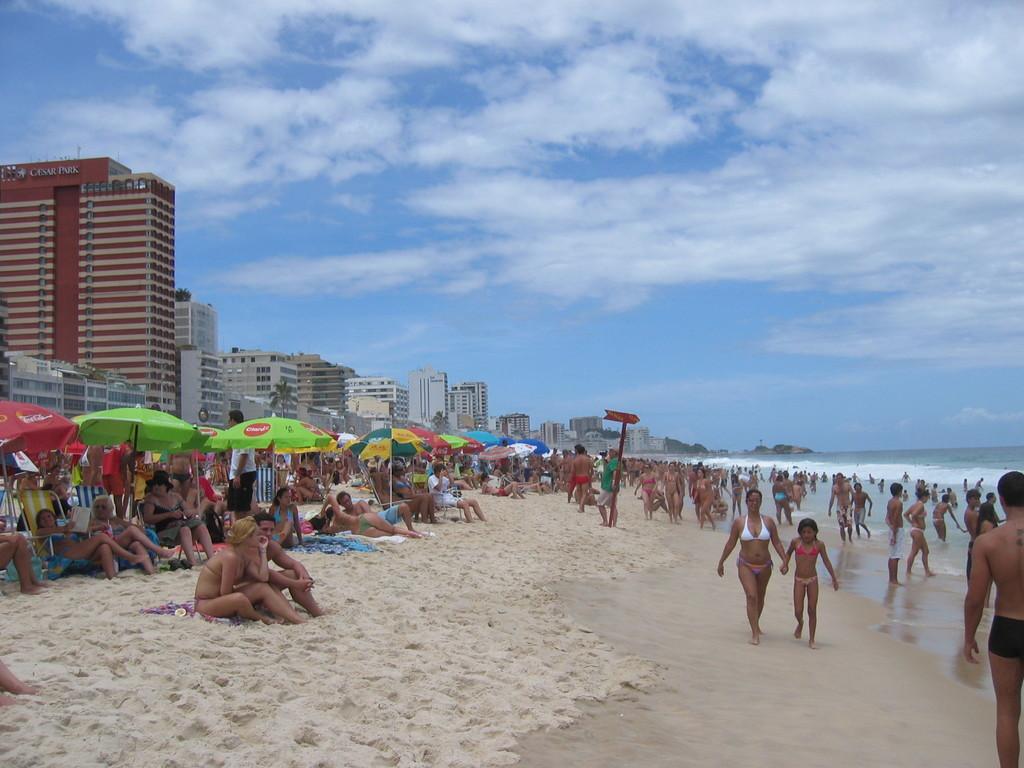Please provide a concise description of this image. Here we can see people, water, umbrellas, signboard, trees and buildings. Sky is cloudy. Few people are sitting on chairs. 